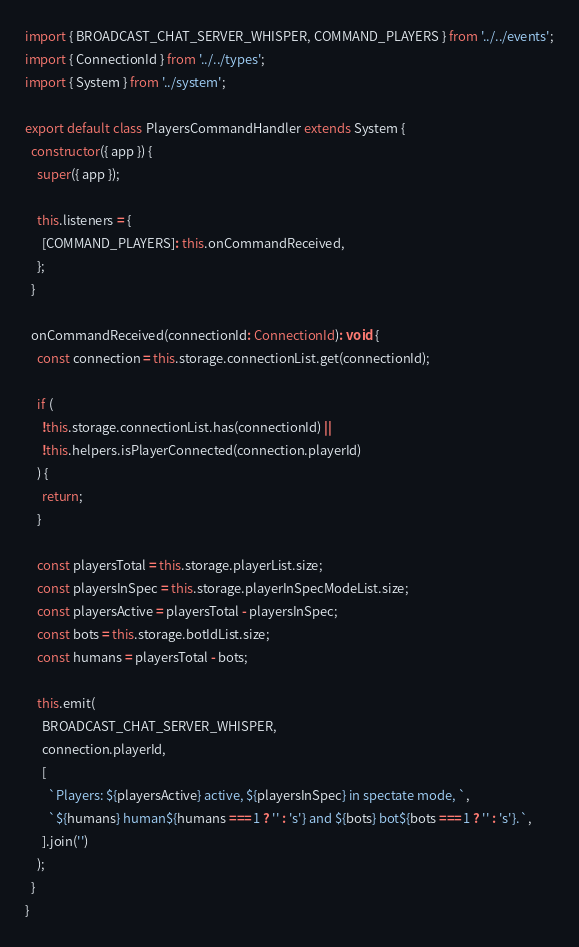Convert code to text. <code><loc_0><loc_0><loc_500><loc_500><_TypeScript_>import { BROADCAST_CHAT_SERVER_WHISPER, COMMAND_PLAYERS } from '../../events';
import { ConnectionId } from '../../types';
import { System } from '../system';

export default class PlayersCommandHandler extends System {
  constructor({ app }) {
    super({ app });

    this.listeners = {
      [COMMAND_PLAYERS]: this.onCommandReceived,
    };
  }

  onCommandReceived(connectionId: ConnectionId): void {
    const connection = this.storage.connectionList.get(connectionId);

    if (
      !this.storage.connectionList.has(connectionId) ||
      !this.helpers.isPlayerConnected(connection.playerId)
    ) {
      return;
    }

    const playersTotal = this.storage.playerList.size;
    const playersInSpec = this.storage.playerInSpecModeList.size;
    const playersActive = playersTotal - playersInSpec;
    const bots = this.storage.botIdList.size;
    const humans = playersTotal - bots;

    this.emit(
      BROADCAST_CHAT_SERVER_WHISPER,
      connection.playerId,
      [
        `Players: ${playersActive} active, ${playersInSpec} in spectate mode, `,
        `${humans} human${humans === 1 ? '' : 's'} and ${bots} bot${bots === 1 ? '' : 's'}.`,
      ].join('')
    );
  }
}
</code> 